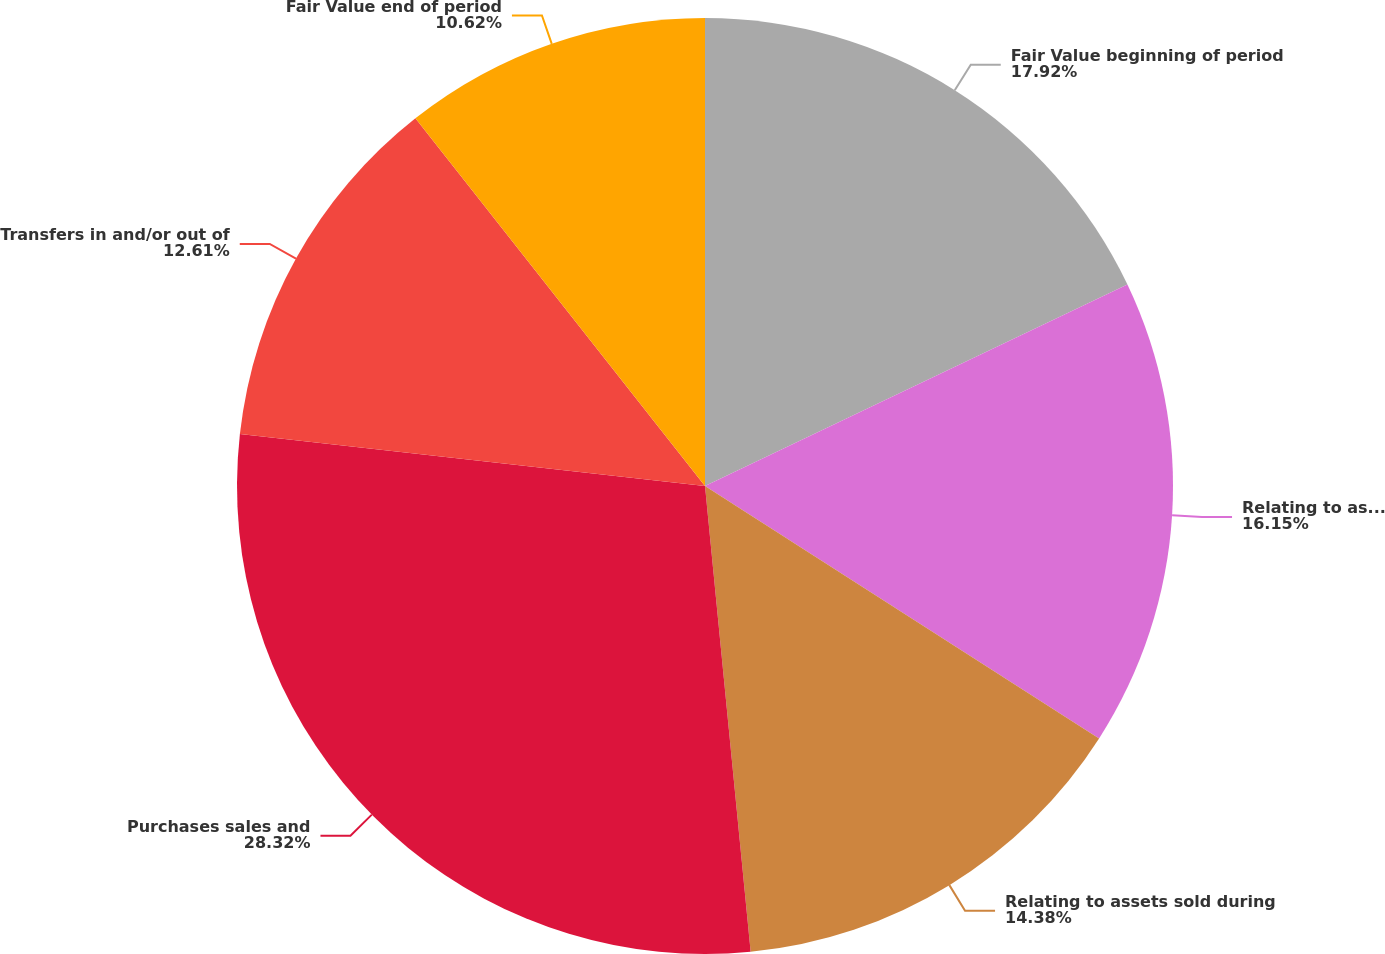Convert chart to OTSL. <chart><loc_0><loc_0><loc_500><loc_500><pie_chart><fcel>Fair Value beginning of period<fcel>Relating to assets still held<fcel>Relating to assets sold during<fcel>Purchases sales and<fcel>Transfers in and/or out of<fcel>Fair Value end of period<nl><fcel>17.92%<fcel>16.15%<fcel>14.38%<fcel>28.33%<fcel>12.61%<fcel>10.62%<nl></chart> 